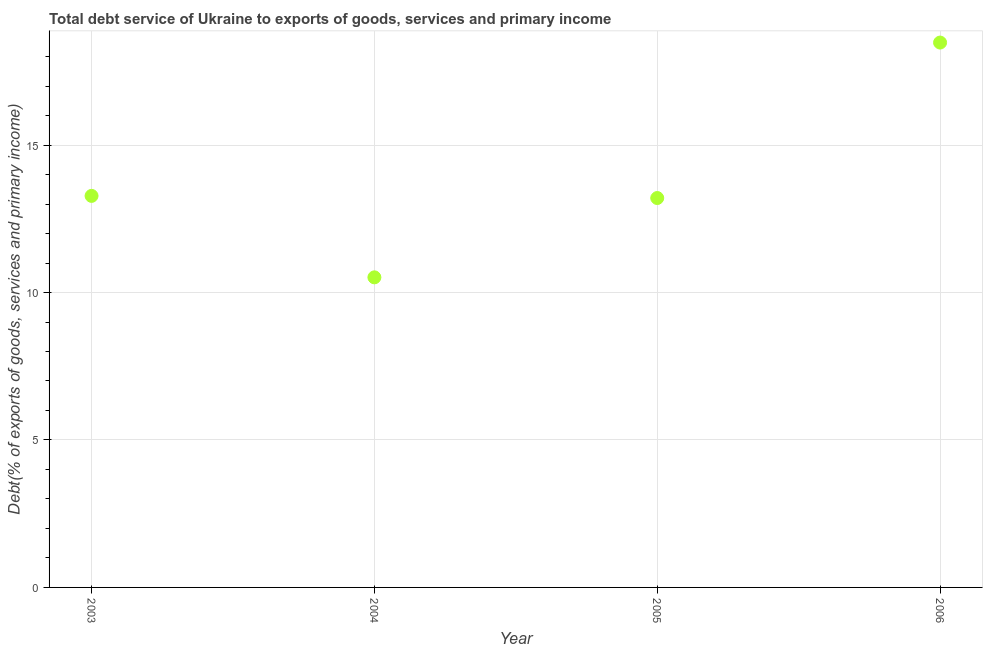What is the total debt service in 2006?
Keep it short and to the point. 18.48. Across all years, what is the maximum total debt service?
Keep it short and to the point. 18.48. Across all years, what is the minimum total debt service?
Ensure brevity in your answer.  10.51. In which year was the total debt service maximum?
Provide a short and direct response. 2006. What is the sum of the total debt service?
Provide a short and direct response. 55.47. What is the difference between the total debt service in 2003 and 2005?
Make the answer very short. 0.07. What is the average total debt service per year?
Your answer should be compact. 13.87. What is the median total debt service?
Ensure brevity in your answer.  13.24. In how many years, is the total debt service greater than 13 %?
Your response must be concise. 3. Do a majority of the years between 2005 and 2004 (inclusive) have total debt service greater than 14 %?
Give a very brief answer. No. What is the ratio of the total debt service in 2004 to that in 2006?
Your response must be concise. 0.57. What is the difference between the highest and the second highest total debt service?
Give a very brief answer. 5.2. What is the difference between the highest and the lowest total debt service?
Your response must be concise. 7.96. In how many years, is the total debt service greater than the average total debt service taken over all years?
Keep it short and to the point. 1. Does the total debt service monotonically increase over the years?
Give a very brief answer. No. How many dotlines are there?
Ensure brevity in your answer.  1. How many years are there in the graph?
Provide a short and direct response. 4. Are the values on the major ticks of Y-axis written in scientific E-notation?
Your response must be concise. No. Does the graph contain any zero values?
Offer a terse response. No. What is the title of the graph?
Keep it short and to the point. Total debt service of Ukraine to exports of goods, services and primary income. What is the label or title of the X-axis?
Offer a terse response. Year. What is the label or title of the Y-axis?
Make the answer very short. Debt(% of exports of goods, services and primary income). What is the Debt(% of exports of goods, services and primary income) in 2003?
Ensure brevity in your answer.  13.28. What is the Debt(% of exports of goods, services and primary income) in 2004?
Provide a short and direct response. 10.51. What is the Debt(% of exports of goods, services and primary income) in 2005?
Give a very brief answer. 13.2. What is the Debt(% of exports of goods, services and primary income) in 2006?
Your answer should be compact. 18.48. What is the difference between the Debt(% of exports of goods, services and primary income) in 2003 and 2004?
Provide a succinct answer. 2.76. What is the difference between the Debt(% of exports of goods, services and primary income) in 2003 and 2005?
Your response must be concise. 0.07. What is the difference between the Debt(% of exports of goods, services and primary income) in 2003 and 2006?
Your response must be concise. -5.2. What is the difference between the Debt(% of exports of goods, services and primary income) in 2004 and 2005?
Your response must be concise. -2.69. What is the difference between the Debt(% of exports of goods, services and primary income) in 2004 and 2006?
Offer a terse response. -7.96. What is the difference between the Debt(% of exports of goods, services and primary income) in 2005 and 2006?
Your response must be concise. -5.27. What is the ratio of the Debt(% of exports of goods, services and primary income) in 2003 to that in 2004?
Your answer should be compact. 1.26. What is the ratio of the Debt(% of exports of goods, services and primary income) in 2003 to that in 2005?
Make the answer very short. 1. What is the ratio of the Debt(% of exports of goods, services and primary income) in 2003 to that in 2006?
Your response must be concise. 0.72. What is the ratio of the Debt(% of exports of goods, services and primary income) in 2004 to that in 2005?
Make the answer very short. 0.8. What is the ratio of the Debt(% of exports of goods, services and primary income) in 2004 to that in 2006?
Offer a very short reply. 0.57. What is the ratio of the Debt(% of exports of goods, services and primary income) in 2005 to that in 2006?
Ensure brevity in your answer.  0.71. 